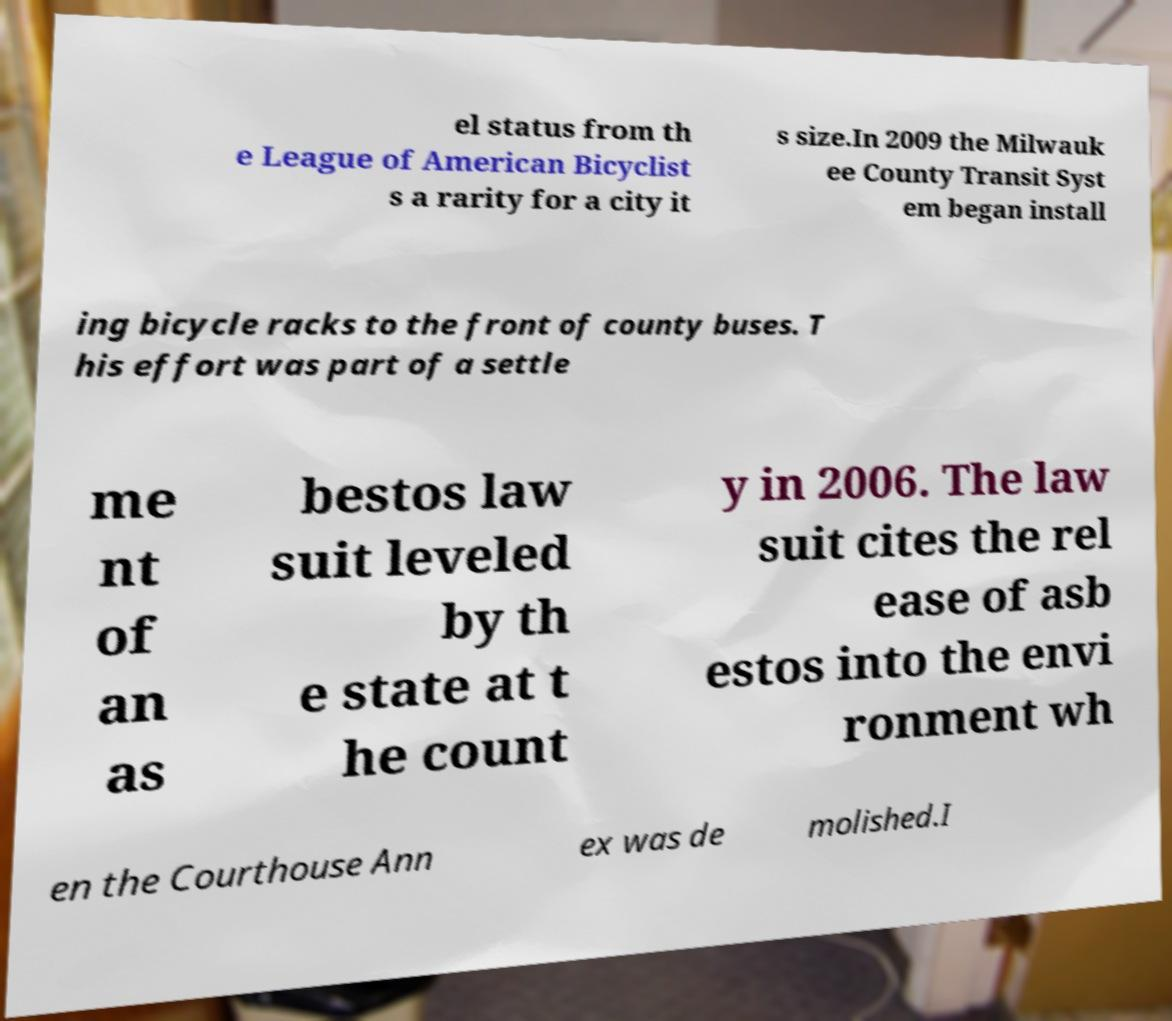Please identify and transcribe the text found in this image. el status from th e League of American Bicyclist s a rarity for a city it s size.In 2009 the Milwauk ee County Transit Syst em began install ing bicycle racks to the front of county buses. T his effort was part of a settle me nt of an as bestos law suit leveled by th e state at t he count y in 2006. The law suit cites the rel ease of asb estos into the envi ronment wh en the Courthouse Ann ex was de molished.I 